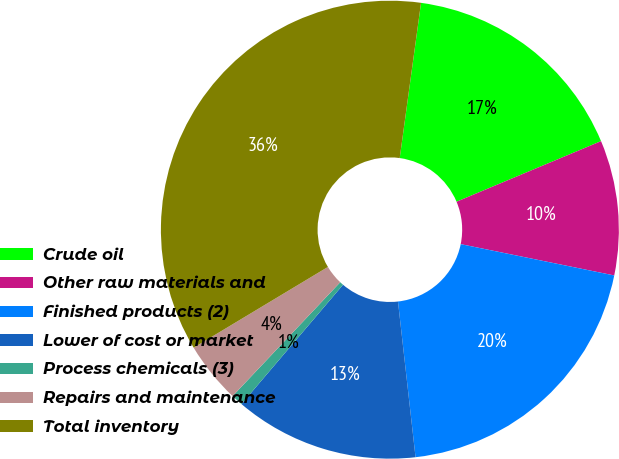Convert chart. <chart><loc_0><loc_0><loc_500><loc_500><pie_chart><fcel>Crude oil<fcel>Other raw materials and<fcel>Finished products (2)<fcel>Lower of cost or market<fcel>Process chemicals (3)<fcel>Repairs and maintenance<fcel>Total inventory<nl><fcel>16.51%<fcel>9.52%<fcel>20.01%<fcel>13.01%<fcel>0.83%<fcel>4.33%<fcel>35.79%<nl></chart> 